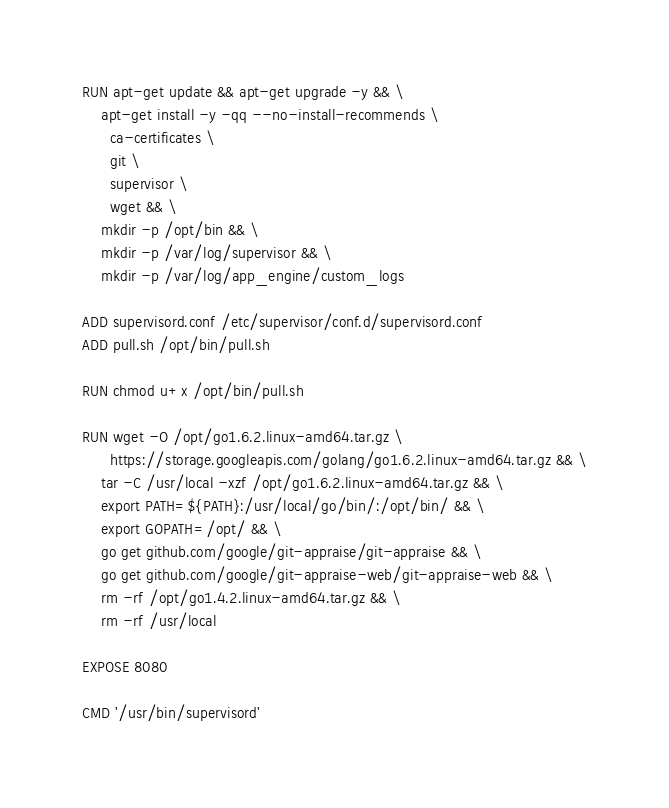<code> <loc_0><loc_0><loc_500><loc_500><_Dockerfile_>
RUN apt-get update && apt-get upgrade -y && \
    apt-get install -y -qq --no-install-recommends \
      ca-certificates \
      git \
      supervisor \
      wget && \
    mkdir -p /opt/bin && \
    mkdir -p /var/log/supervisor && \
    mkdir -p /var/log/app_engine/custom_logs

ADD supervisord.conf /etc/supervisor/conf.d/supervisord.conf
ADD pull.sh /opt/bin/pull.sh

RUN chmod u+x /opt/bin/pull.sh

RUN wget -O /opt/go1.6.2.linux-amd64.tar.gz \
      https://storage.googleapis.com/golang/go1.6.2.linux-amd64.tar.gz && \
    tar -C /usr/local -xzf /opt/go1.6.2.linux-amd64.tar.gz && \
    export PATH=${PATH}:/usr/local/go/bin/:/opt/bin/ && \
    export GOPATH=/opt/ && \
    go get github.com/google/git-appraise/git-appraise && \
    go get github.com/google/git-appraise-web/git-appraise-web && \
    rm -rf /opt/go1.4.2.linux-amd64.tar.gz && \
    rm -rf /usr/local

EXPOSE 8080

CMD '/usr/bin/supervisord'
</code> 